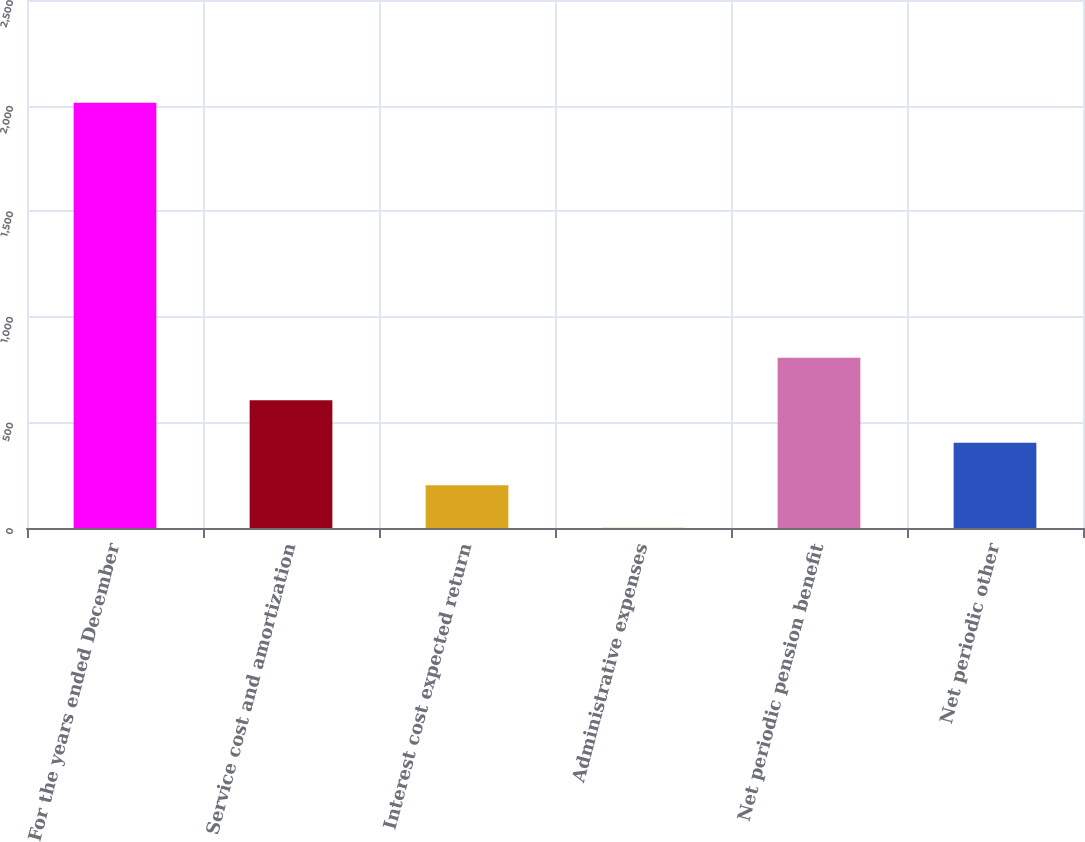Convert chart. <chart><loc_0><loc_0><loc_500><loc_500><bar_chart><fcel>For the years ended December<fcel>Service cost and amortization<fcel>Interest cost expected return<fcel>Administrative expenses<fcel>Net periodic pension benefit<fcel>Net periodic other<nl><fcel>2013<fcel>604.39<fcel>201.93<fcel>0.7<fcel>805.62<fcel>403.16<nl></chart> 